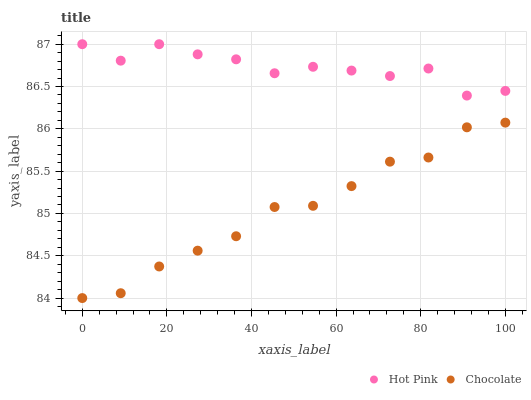Does Chocolate have the minimum area under the curve?
Answer yes or no. Yes. Does Hot Pink have the maximum area under the curve?
Answer yes or no. Yes. Does Chocolate have the maximum area under the curve?
Answer yes or no. No. Is Chocolate the smoothest?
Answer yes or no. Yes. Is Hot Pink the roughest?
Answer yes or no. Yes. Is Chocolate the roughest?
Answer yes or no. No. Does Chocolate have the lowest value?
Answer yes or no. Yes. Does Hot Pink have the highest value?
Answer yes or no. Yes. Does Chocolate have the highest value?
Answer yes or no. No. Is Chocolate less than Hot Pink?
Answer yes or no. Yes. Is Hot Pink greater than Chocolate?
Answer yes or no. Yes. Does Chocolate intersect Hot Pink?
Answer yes or no. No. 